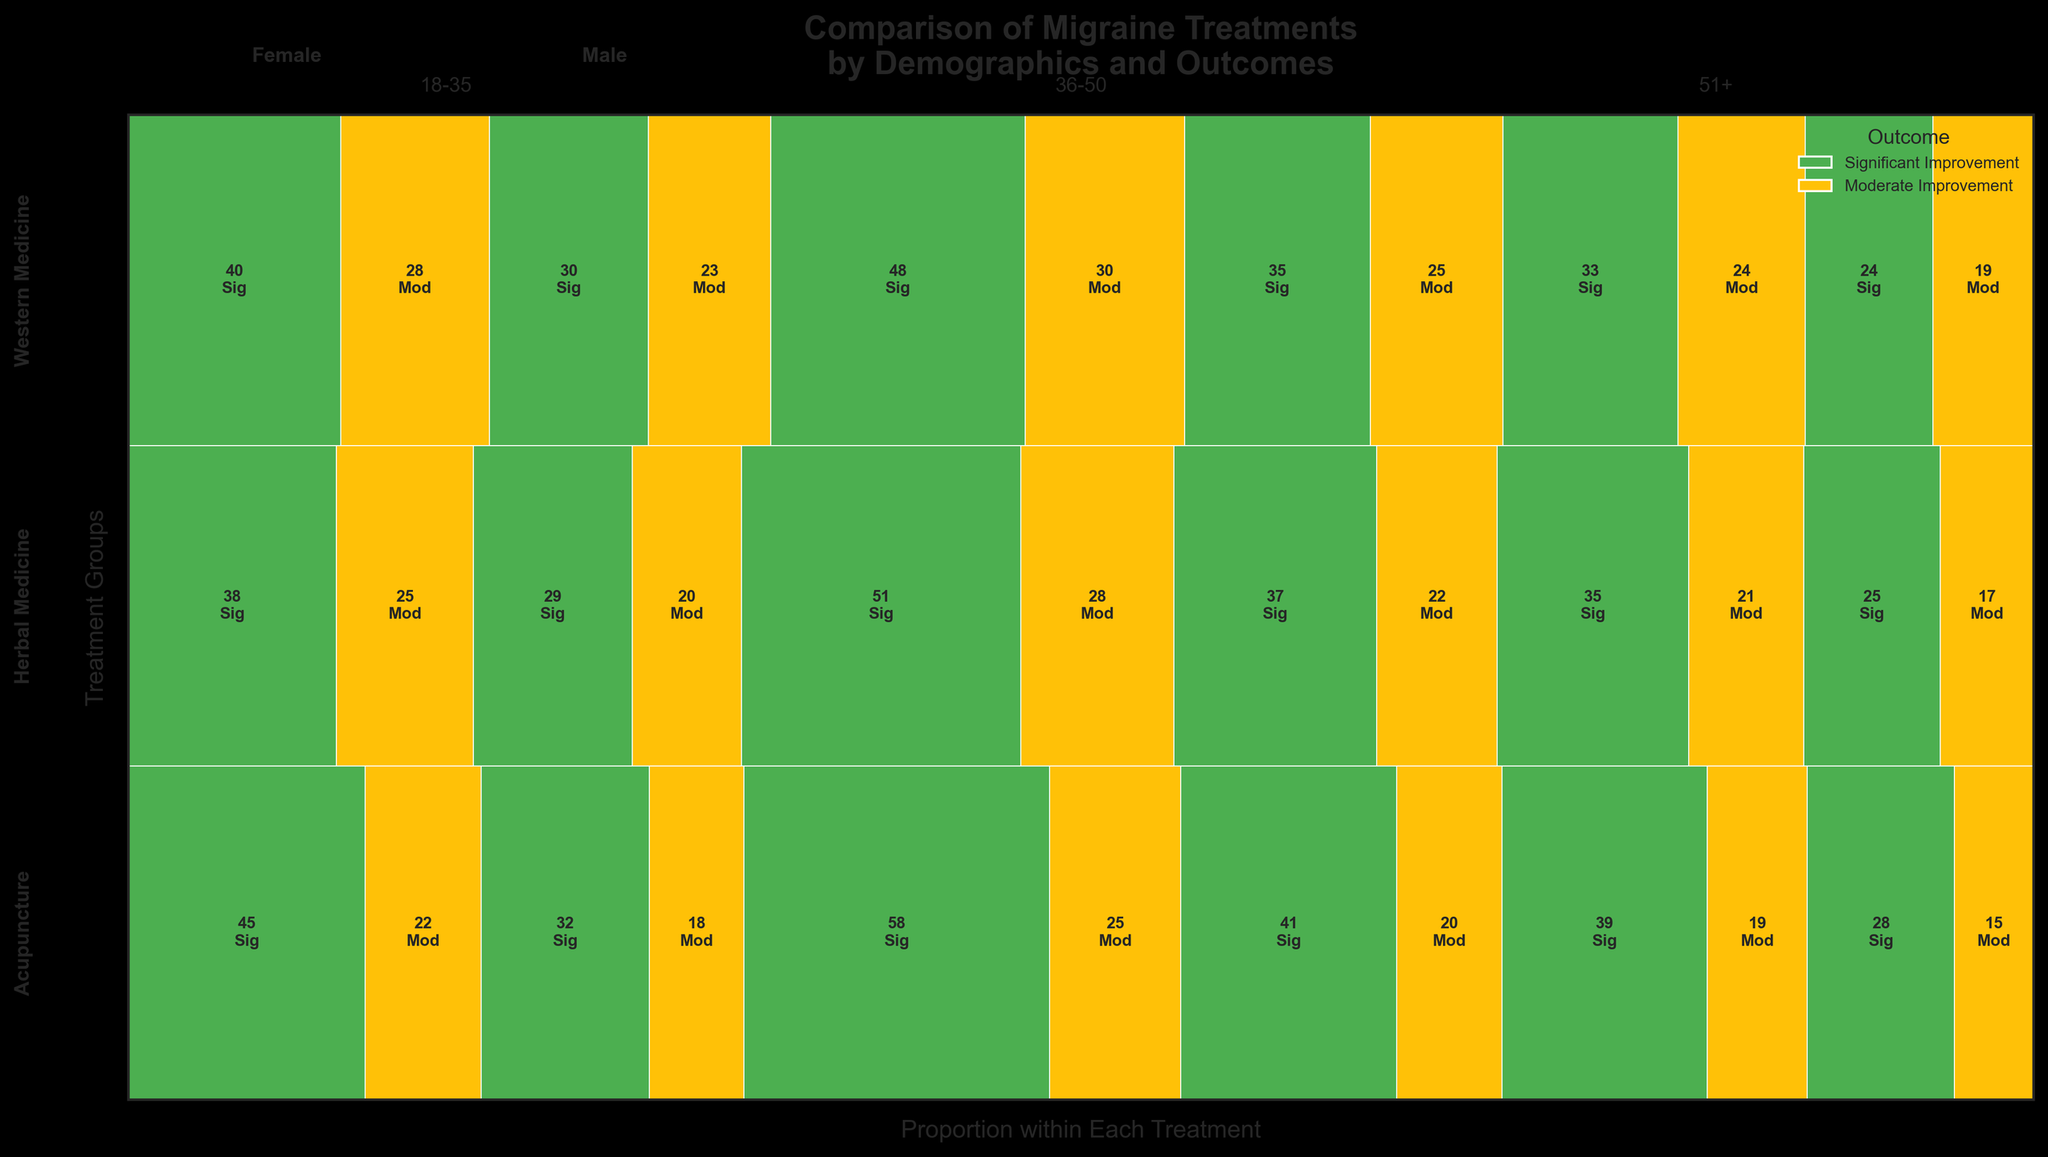How many significant improvement outcomes were recorded for females aged 36-50 using acupuncture? Locate the mosaic plot section corresponding to females aged 36-50 receiving acupuncture. The rectangle's color indicates significant improvement. The count label inside this section shows the value.
Answer: 58 Are there more significant improvement outcomes for males aged 18-35 using herbal medicine or western medicine? Compare the mosaic plot sections for males aged 18-35 using herbal medicine and western medicine. Check the counts in the sections colored for significant improvement.
Answer: Western medicine Which age group had the highest count of significant improvement outcomes under acupuncture for both genders combined? Sum the counts of significant improvement outcomes for both males and females within each age group under acupuncture and compare them.
Answer: 36-50 Is the proportion of moderate improvement outcomes higher for herbal medicine in the 51+ age group compared to western medicine in the same age group? Compare the widths of moderate improvement rectangles for herbal medicine and western medicine within the 51+ age group. Wider rectangles represent a higher proportion.
Answer: No What is the combined total of significant improvement outcomes for all treatments across all age groups for females? Sum up the counts of significant improvement outcomes for females across all age groups and treatments in the mosaic plot.
Answer: 450 